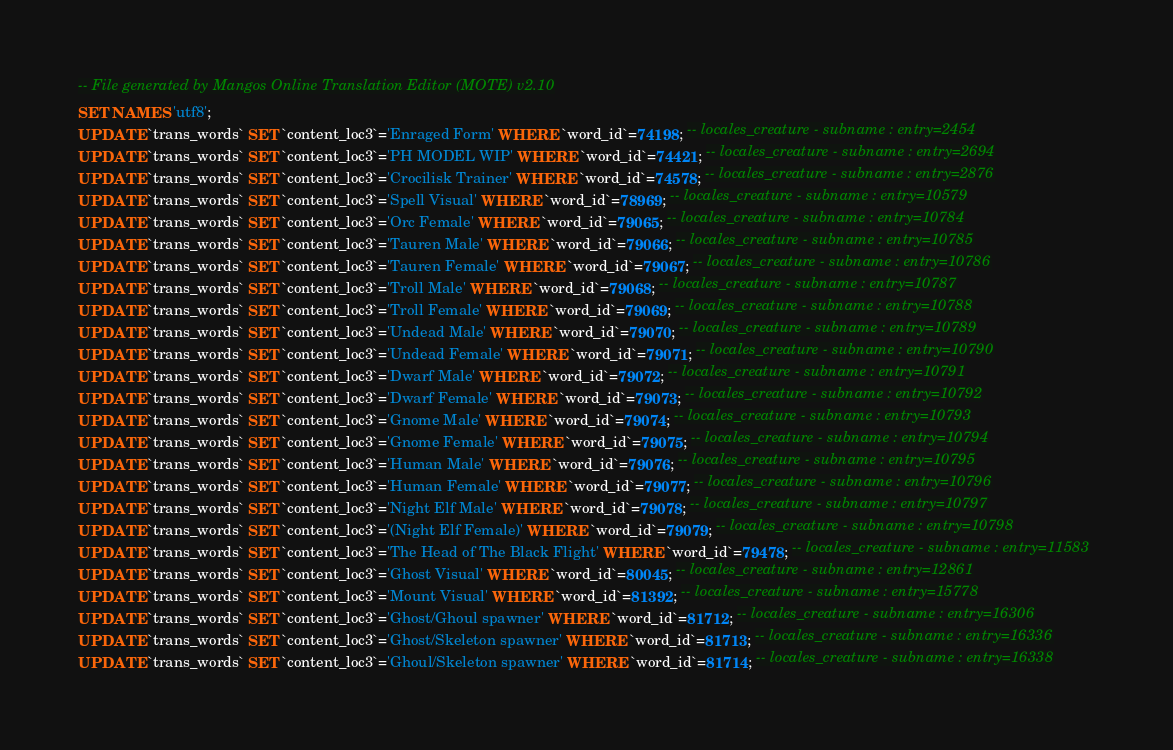Convert code to text. <code><loc_0><loc_0><loc_500><loc_500><_SQL_>-- File generated by Mangos Online Translation Editor (MOTE) v2.10
SET NAMES 'utf8';
UPDATE `trans_words` SET `content_loc3`='Enraged Form' WHERE `word_id`=74198; -- locales_creature - subname : entry=2454
UPDATE `trans_words` SET `content_loc3`='PH MODEL WIP' WHERE `word_id`=74421; -- locales_creature - subname : entry=2694
UPDATE `trans_words` SET `content_loc3`='Crocilisk Trainer' WHERE `word_id`=74578; -- locales_creature - subname : entry=2876
UPDATE `trans_words` SET `content_loc3`='Spell Visual' WHERE `word_id`=78969; -- locales_creature - subname : entry=10579
UPDATE `trans_words` SET `content_loc3`='Orc Female' WHERE `word_id`=79065; -- locales_creature - subname : entry=10784
UPDATE `trans_words` SET `content_loc3`='Tauren Male' WHERE `word_id`=79066; -- locales_creature - subname : entry=10785
UPDATE `trans_words` SET `content_loc3`='Tauren Female' WHERE `word_id`=79067; -- locales_creature - subname : entry=10786
UPDATE `trans_words` SET `content_loc3`='Troll Male' WHERE `word_id`=79068; -- locales_creature - subname : entry=10787
UPDATE `trans_words` SET `content_loc3`='Troll Female' WHERE `word_id`=79069; -- locales_creature - subname : entry=10788
UPDATE `trans_words` SET `content_loc3`='Undead Male' WHERE `word_id`=79070; -- locales_creature - subname : entry=10789
UPDATE `trans_words` SET `content_loc3`='Undead Female' WHERE `word_id`=79071; -- locales_creature - subname : entry=10790
UPDATE `trans_words` SET `content_loc3`='Dwarf Male' WHERE `word_id`=79072; -- locales_creature - subname : entry=10791
UPDATE `trans_words` SET `content_loc3`='Dwarf Female' WHERE `word_id`=79073; -- locales_creature - subname : entry=10792
UPDATE `trans_words` SET `content_loc3`='Gnome Male' WHERE `word_id`=79074; -- locales_creature - subname : entry=10793
UPDATE `trans_words` SET `content_loc3`='Gnome Female' WHERE `word_id`=79075; -- locales_creature - subname : entry=10794
UPDATE `trans_words` SET `content_loc3`='Human Male' WHERE `word_id`=79076; -- locales_creature - subname : entry=10795
UPDATE `trans_words` SET `content_loc3`='Human Female' WHERE `word_id`=79077; -- locales_creature - subname : entry=10796
UPDATE `trans_words` SET `content_loc3`='Night Elf Male' WHERE `word_id`=79078; -- locales_creature - subname : entry=10797
UPDATE `trans_words` SET `content_loc3`='(Night Elf Female)' WHERE `word_id`=79079; -- locales_creature - subname : entry=10798
UPDATE `trans_words` SET `content_loc3`='The Head of The Black Flight' WHERE `word_id`=79478; -- locales_creature - subname : entry=11583
UPDATE `trans_words` SET `content_loc3`='Ghost Visual' WHERE `word_id`=80045; -- locales_creature - subname : entry=12861
UPDATE `trans_words` SET `content_loc3`='Mount Visual' WHERE `word_id`=81392; -- locales_creature - subname : entry=15778
UPDATE `trans_words` SET `content_loc3`='Ghost/Ghoul spawner' WHERE `word_id`=81712; -- locales_creature - subname : entry=16306
UPDATE `trans_words` SET `content_loc3`='Ghost/Skeleton spawner' WHERE `word_id`=81713; -- locales_creature - subname : entry=16336
UPDATE `trans_words` SET `content_loc3`='Ghoul/Skeleton spawner' WHERE `word_id`=81714; -- locales_creature - subname : entry=16338</code> 